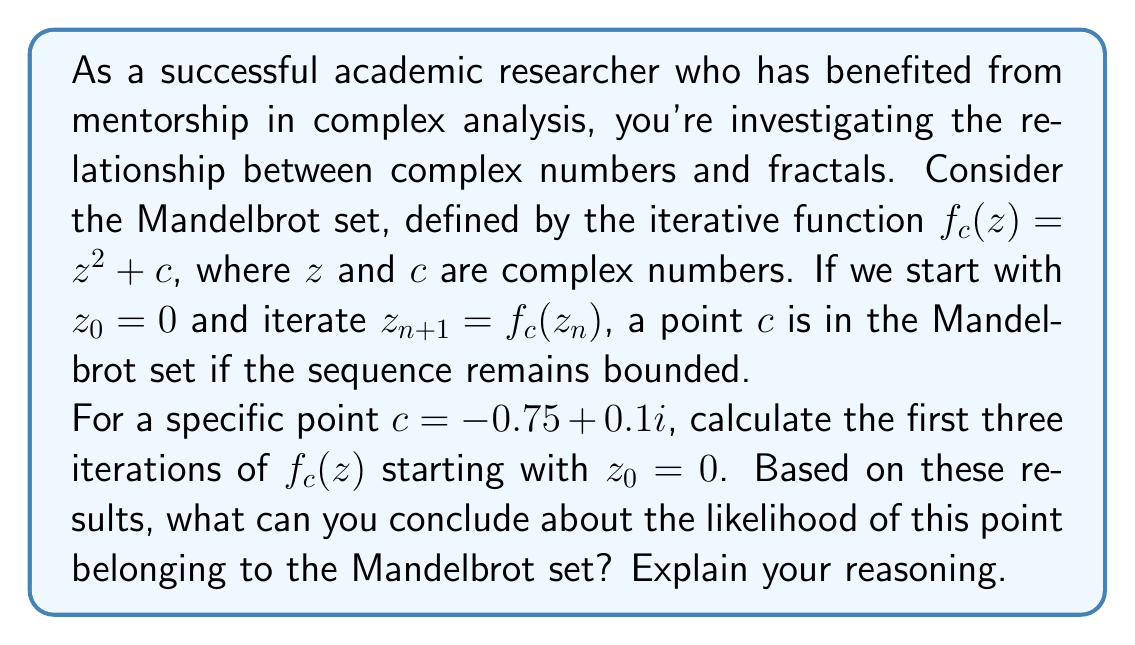Could you help me with this problem? Let's approach this step-by-step:

1) We start with the function $f_c(z) = z^2 + c$, where $c = -0.75 + 0.1i$.

2) We begin with $z_0 = 0$ and calculate the first three iterations:

   For $z_1$:
   $$z_1 = f_c(z_0) = (0)^2 + (-0.75 + 0.1i) = -0.75 + 0.1i$$

   For $z_2$:
   $$\begin{align}
   z_2 &= f_c(z_1) = (-0.75 + 0.1i)^2 + (-0.75 + 0.1i) \\
   &= (0.5625 - 0.15i + 0.01) + (-0.75 + 0.1i) \\
   &= -0.1875 - 0.05i
   \end{align}$$

   For $z_3$:
   $$\begin{align}
   z_3 &= f_c(z_2) = (-0.1875 - 0.05i)^2 + (-0.75 + 0.1i) \\
   &= (0.035156 + 0.01875i + 0.0025) + (-0.75 + 0.1i) \\
   &= -0.712344 + 0.11875i
   \end{align}$$

3) To determine if a point is likely to be in the Mandelbrot set, we look at whether the sequence appears to be bounded or if it's growing without limit.

4) In this case, we observe that:
   $|z_1| \approx 0.7566$
   $|z_2| \approx 0.1944$
   $|z_3| \approx 0.7221$

5) We can see that the absolute values are not growing significantly. In fact, they're oscillating within a relatively small range.

6) This behavior suggests that the sequence might remain bounded as we continue to iterate.

Based on this analysis, we can conclude that the point $c = -0.75 + 0.1i$ is likely to be within or very close to the Mandelbrot set. However, it's important to note that a definitive conclusion would require either mathematical proof or many more iterations to be certain.
Answer: Based on the first three iterations, the point $c = -0.75 + 0.1i$ is likely to belong to the Mandelbrot set, as the sequence appears to remain bounded within a small range. 